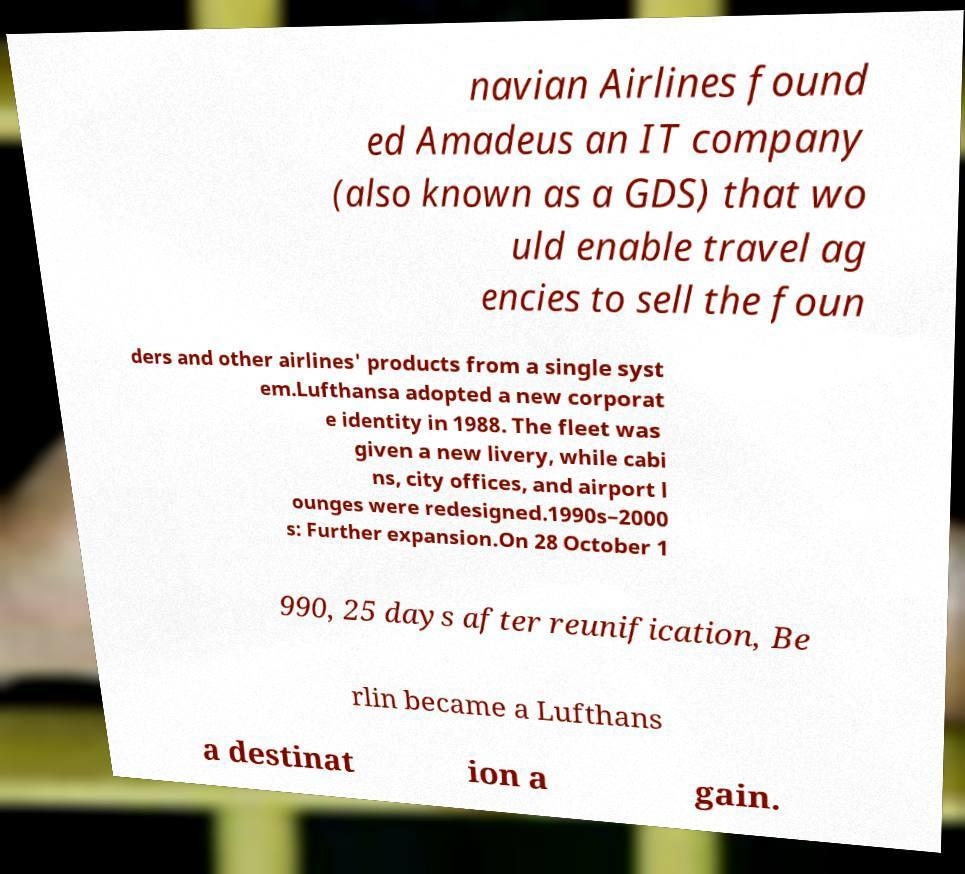I need the written content from this picture converted into text. Can you do that? navian Airlines found ed Amadeus an IT company (also known as a GDS) that wo uld enable travel ag encies to sell the foun ders and other airlines' products from a single syst em.Lufthansa adopted a new corporat e identity in 1988. The fleet was given a new livery, while cabi ns, city offices, and airport l ounges were redesigned.1990s–2000 s: Further expansion.On 28 October 1 990, 25 days after reunification, Be rlin became a Lufthans a destinat ion a gain. 